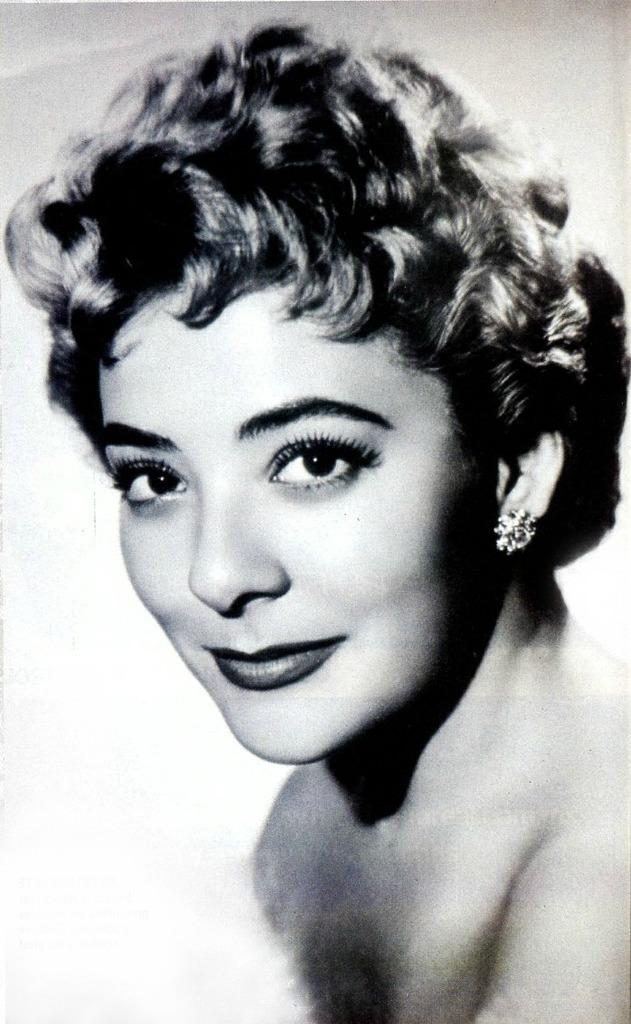Who is present in the image? There is a woman in the image. What is the woman doing in the image? The woman is smiling in the image. What is the color scheme of the image? The image is in black and white. Where is the library located in the image? There is no library present in the image; it features a woman smiling. What is the woman using to protect her head in the image? There is no head protection visible in the image, as it only shows a woman smiling in black and white. 